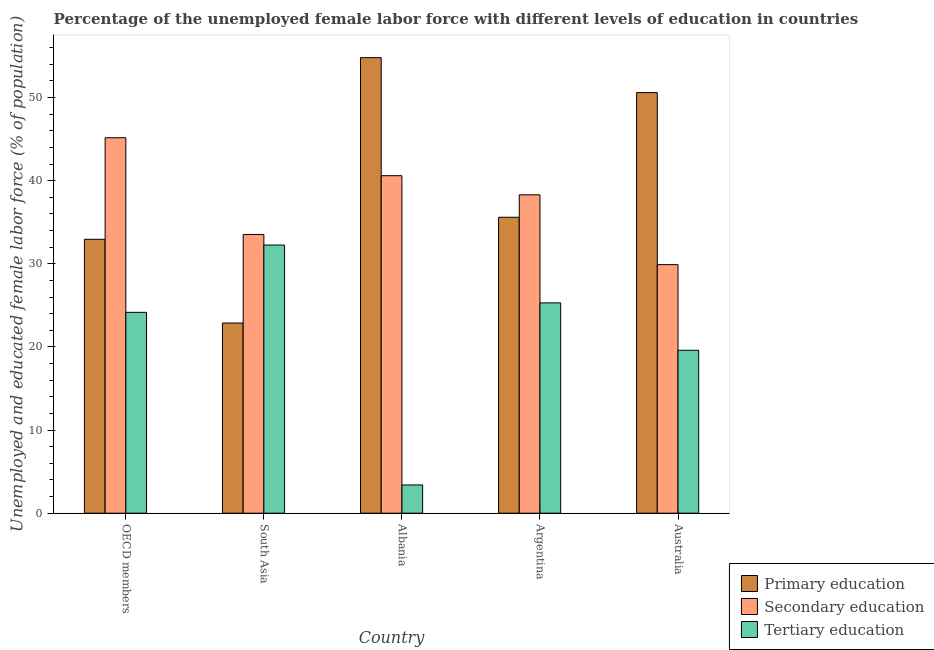Are the number of bars per tick equal to the number of legend labels?
Offer a terse response. Yes. Are the number of bars on each tick of the X-axis equal?
Keep it short and to the point. Yes. How many bars are there on the 3rd tick from the left?
Your answer should be compact. 3. How many bars are there on the 1st tick from the right?
Your answer should be very brief. 3. What is the label of the 3rd group of bars from the left?
Offer a terse response. Albania. What is the percentage of female labor force who received secondary education in South Asia?
Give a very brief answer. 33.53. Across all countries, what is the maximum percentage of female labor force who received primary education?
Your answer should be very brief. 54.8. Across all countries, what is the minimum percentage of female labor force who received secondary education?
Make the answer very short. 29.9. What is the total percentage of female labor force who received tertiary education in the graph?
Make the answer very short. 104.72. What is the difference between the percentage of female labor force who received secondary education in OECD members and that in South Asia?
Ensure brevity in your answer.  11.63. What is the difference between the percentage of female labor force who received secondary education in Argentina and the percentage of female labor force who received primary education in OECD members?
Make the answer very short. 5.35. What is the average percentage of female labor force who received secondary education per country?
Your response must be concise. 37.5. What is the difference between the percentage of female labor force who received primary education and percentage of female labor force who received secondary education in Albania?
Your answer should be very brief. 14.2. What is the ratio of the percentage of female labor force who received tertiary education in Albania to that in OECD members?
Ensure brevity in your answer.  0.14. Is the difference between the percentage of female labor force who received secondary education in Argentina and Australia greater than the difference between the percentage of female labor force who received primary education in Argentina and Australia?
Provide a succinct answer. Yes. What is the difference between the highest and the second highest percentage of female labor force who received tertiary education?
Provide a succinct answer. 6.96. What is the difference between the highest and the lowest percentage of female labor force who received tertiary education?
Keep it short and to the point. 28.86. Is the sum of the percentage of female labor force who received primary education in Albania and Australia greater than the maximum percentage of female labor force who received secondary education across all countries?
Your response must be concise. Yes. What does the 1st bar from the left in South Asia represents?
Ensure brevity in your answer.  Primary education. What does the 1st bar from the right in Argentina represents?
Your answer should be very brief. Tertiary education. Is it the case that in every country, the sum of the percentage of female labor force who received primary education and percentage of female labor force who received secondary education is greater than the percentage of female labor force who received tertiary education?
Keep it short and to the point. Yes. How many bars are there?
Your answer should be compact. 15. Are all the bars in the graph horizontal?
Give a very brief answer. No. What is the difference between two consecutive major ticks on the Y-axis?
Provide a short and direct response. 10. Are the values on the major ticks of Y-axis written in scientific E-notation?
Keep it short and to the point. No. What is the title of the graph?
Make the answer very short. Percentage of the unemployed female labor force with different levels of education in countries. Does "Oil" appear as one of the legend labels in the graph?
Make the answer very short. No. What is the label or title of the X-axis?
Your answer should be very brief. Country. What is the label or title of the Y-axis?
Your answer should be very brief. Unemployed and educated female labor force (% of population). What is the Unemployed and educated female labor force (% of population) of Primary education in OECD members?
Offer a very short reply. 32.95. What is the Unemployed and educated female labor force (% of population) in Secondary education in OECD members?
Ensure brevity in your answer.  45.16. What is the Unemployed and educated female labor force (% of population) of Tertiary education in OECD members?
Your answer should be compact. 24.16. What is the Unemployed and educated female labor force (% of population) of Primary education in South Asia?
Keep it short and to the point. 22.88. What is the Unemployed and educated female labor force (% of population) of Secondary education in South Asia?
Your answer should be very brief. 33.53. What is the Unemployed and educated female labor force (% of population) of Tertiary education in South Asia?
Offer a terse response. 32.26. What is the Unemployed and educated female labor force (% of population) of Primary education in Albania?
Your response must be concise. 54.8. What is the Unemployed and educated female labor force (% of population) in Secondary education in Albania?
Provide a short and direct response. 40.6. What is the Unemployed and educated female labor force (% of population) of Tertiary education in Albania?
Provide a short and direct response. 3.4. What is the Unemployed and educated female labor force (% of population) of Primary education in Argentina?
Provide a short and direct response. 35.6. What is the Unemployed and educated female labor force (% of population) of Secondary education in Argentina?
Provide a short and direct response. 38.3. What is the Unemployed and educated female labor force (% of population) in Tertiary education in Argentina?
Your answer should be compact. 25.3. What is the Unemployed and educated female labor force (% of population) in Primary education in Australia?
Keep it short and to the point. 50.6. What is the Unemployed and educated female labor force (% of population) in Secondary education in Australia?
Your answer should be very brief. 29.9. What is the Unemployed and educated female labor force (% of population) of Tertiary education in Australia?
Provide a succinct answer. 19.6. Across all countries, what is the maximum Unemployed and educated female labor force (% of population) of Primary education?
Offer a terse response. 54.8. Across all countries, what is the maximum Unemployed and educated female labor force (% of population) in Secondary education?
Make the answer very short. 45.16. Across all countries, what is the maximum Unemployed and educated female labor force (% of population) of Tertiary education?
Ensure brevity in your answer.  32.26. Across all countries, what is the minimum Unemployed and educated female labor force (% of population) of Primary education?
Offer a very short reply. 22.88. Across all countries, what is the minimum Unemployed and educated female labor force (% of population) of Secondary education?
Provide a short and direct response. 29.9. Across all countries, what is the minimum Unemployed and educated female labor force (% of population) in Tertiary education?
Your response must be concise. 3.4. What is the total Unemployed and educated female labor force (% of population) in Primary education in the graph?
Ensure brevity in your answer.  196.83. What is the total Unemployed and educated female labor force (% of population) in Secondary education in the graph?
Your answer should be very brief. 187.5. What is the total Unemployed and educated female labor force (% of population) of Tertiary education in the graph?
Your response must be concise. 104.72. What is the difference between the Unemployed and educated female labor force (% of population) of Primary education in OECD members and that in South Asia?
Ensure brevity in your answer.  10.07. What is the difference between the Unemployed and educated female labor force (% of population) in Secondary education in OECD members and that in South Asia?
Make the answer very short. 11.63. What is the difference between the Unemployed and educated female labor force (% of population) of Tertiary education in OECD members and that in South Asia?
Provide a short and direct response. -8.09. What is the difference between the Unemployed and educated female labor force (% of population) of Primary education in OECD members and that in Albania?
Provide a succinct answer. -21.85. What is the difference between the Unemployed and educated female labor force (% of population) of Secondary education in OECD members and that in Albania?
Provide a succinct answer. 4.56. What is the difference between the Unemployed and educated female labor force (% of population) in Tertiary education in OECD members and that in Albania?
Your response must be concise. 20.76. What is the difference between the Unemployed and educated female labor force (% of population) of Primary education in OECD members and that in Argentina?
Your response must be concise. -2.65. What is the difference between the Unemployed and educated female labor force (% of population) of Secondary education in OECD members and that in Argentina?
Make the answer very short. 6.86. What is the difference between the Unemployed and educated female labor force (% of population) in Tertiary education in OECD members and that in Argentina?
Provide a short and direct response. -1.14. What is the difference between the Unemployed and educated female labor force (% of population) in Primary education in OECD members and that in Australia?
Give a very brief answer. -17.65. What is the difference between the Unemployed and educated female labor force (% of population) in Secondary education in OECD members and that in Australia?
Offer a terse response. 15.26. What is the difference between the Unemployed and educated female labor force (% of population) in Tertiary education in OECD members and that in Australia?
Offer a terse response. 4.56. What is the difference between the Unemployed and educated female labor force (% of population) of Primary education in South Asia and that in Albania?
Provide a short and direct response. -31.92. What is the difference between the Unemployed and educated female labor force (% of population) of Secondary education in South Asia and that in Albania?
Make the answer very short. -7.07. What is the difference between the Unemployed and educated female labor force (% of population) in Tertiary education in South Asia and that in Albania?
Ensure brevity in your answer.  28.86. What is the difference between the Unemployed and educated female labor force (% of population) in Primary education in South Asia and that in Argentina?
Offer a very short reply. -12.72. What is the difference between the Unemployed and educated female labor force (% of population) of Secondary education in South Asia and that in Argentina?
Make the answer very short. -4.77. What is the difference between the Unemployed and educated female labor force (% of population) of Tertiary education in South Asia and that in Argentina?
Ensure brevity in your answer.  6.96. What is the difference between the Unemployed and educated female labor force (% of population) of Primary education in South Asia and that in Australia?
Provide a short and direct response. -27.72. What is the difference between the Unemployed and educated female labor force (% of population) of Secondary education in South Asia and that in Australia?
Keep it short and to the point. 3.63. What is the difference between the Unemployed and educated female labor force (% of population) in Tertiary education in South Asia and that in Australia?
Make the answer very short. 12.66. What is the difference between the Unemployed and educated female labor force (% of population) in Primary education in Albania and that in Argentina?
Your answer should be compact. 19.2. What is the difference between the Unemployed and educated female labor force (% of population) of Tertiary education in Albania and that in Argentina?
Ensure brevity in your answer.  -21.9. What is the difference between the Unemployed and educated female labor force (% of population) of Tertiary education in Albania and that in Australia?
Offer a terse response. -16.2. What is the difference between the Unemployed and educated female labor force (% of population) of Tertiary education in Argentina and that in Australia?
Your answer should be compact. 5.7. What is the difference between the Unemployed and educated female labor force (% of population) of Primary education in OECD members and the Unemployed and educated female labor force (% of population) of Secondary education in South Asia?
Provide a succinct answer. -0.58. What is the difference between the Unemployed and educated female labor force (% of population) of Primary education in OECD members and the Unemployed and educated female labor force (% of population) of Tertiary education in South Asia?
Keep it short and to the point. 0.69. What is the difference between the Unemployed and educated female labor force (% of population) in Secondary education in OECD members and the Unemployed and educated female labor force (% of population) in Tertiary education in South Asia?
Make the answer very short. 12.91. What is the difference between the Unemployed and educated female labor force (% of population) in Primary education in OECD members and the Unemployed and educated female labor force (% of population) in Secondary education in Albania?
Your answer should be compact. -7.65. What is the difference between the Unemployed and educated female labor force (% of population) of Primary education in OECD members and the Unemployed and educated female labor force (% of population) of Tertiary education in Albania?
Ensure brevity in your answer.  29.55. What is the difference between the Unemployed and educated female labor force (% of population) in Secondary education in OECD members and the Unemployed and educated female labor force (% of population) in Tertiary education in Albania?
Provide a succinct answer. 41.76. What is the difference between the Unemployed and educated female labor force (% of population) of Primary education in OECD members and the Unemployed and educated female labor force (% of population) of Secondary education in Argentina?
Your answer should be very brief. -5.35. What is the difference between the Unemployed and educated female labor force (% of population) of Primary education in OECD members and the Unemployed and educated female labor force (% of population) of Tertiary education in Argentina?
Provide a succinct answer. 7.65. What is the difference between the Unemployed and educated female labor force (% of population) of Secondary education in OECD members and the Unemployed and educated female labor force (% of population) of Tertiary education in Argentina?
Give a very brief answer. 19.86. What is the difference between the Unemployed and educated female labor force (% of population) in Primary education in OECD members and the Unemployed and educated female labor force (% of population) in Secondary education in Australia?
Ensure brevity in your answer.  3.05. What is the difference between the Unemployed and educated female labor force (% of population) of Primary education in OECD members and the Unemployed and educated female labor force (% of population) of Tertiary education in Australia?
Keep it short and to the point. 13.35. What is the difference between the Unemployed and educated female labor force (% of population) in Secondary education in OECD members and the Unemployed and educated female labor force (% of population) in Tertiary education in Australia?
Give a very brief answer. 25.56. What is the difference between the Unemployed and educated female labor force (% of population) of Primary education in South Asia and the Unemployed and educated female labor force (% of population) of Secondary education in Albania?
Your answer should be very brief. -17.72. What is the difference between the Unemployed and educated female labor force (% of population) of Primary education in South Asia and the Unemployed and educated female labor force (% of population) of Tertiary education in Albania?
Ensure brevity in your answer.  19.48. What is the difference between the Unemployed and educated female labor force (% of population) of Secondary education in South Asia and the Unemployed and educated female labor force (% of population) of Tertiary education in Albania?
Offer a terse response. 30.13. What is the difference between the Unemployed and educated female labor force (% of population) of Primary education in South Asia and the Unemployed and educated female labor force (% of population) of Secondary education in Argentina?
Your answer should be compact. -15.42. What is the difference between the Unemployed and educated female labor force (% of population) of Primary education in South Asia and the Unemployed and educated female labor force (% of population) of Tertiary education in Argentina?
Your answer should be compact. -2.42. What is the difference between the Unemployed and educated female labor force (% of population) of Secondary education in South Asia and the Unemployed and educated female labor force (% of population) of Tertiary education in Argentina?
Offer a terse response. 8.23. What is the difference between the Unemployed and educated female labor force (% of population) of Primary education in South Asia and the Unemployed and educated female labor force (% of population) of Secondary education in Australia?
Your answer should be compact. -7.02. What is the difference between the Unemployed and educated female labor force (% of population) of Primary education in South Asia and the Unemployed and educated female labor force (% of population) of Tertiary education in Australia?
Keep it short and to the point. 3.28. What is the difference between the Unemployed and educated female labor force (% of population) of Secondary education in South Asia and the Unemployed and educated female labor force (% of population) of Tertiary education in Australia?
Keep it short and to the point. 13.93. What is the difference between the Unemployed and educated female labor force (% of population) of Primary education in Albania and the Unemployed and educated female labor force (% of population) of Secondary education in Argentina?
Offer a terse response. 16.5. What is the difference between the Unemployed and educated female labor force (% of population) of Primary education in Albania and the Unemployed and educated female labor force (% of population) of Tertiary education in Argentina?
Make the answer very short. 29.5. What is the difference between the Unemployed and educated female labor force (% of population) in Secondary education in Albania and the Unemployed and educated female labor force (% of population) in Tertiary education in Argentina?
Give a very brief answer. 15.3. What is the difference between the Unemployed and educated female labor force (% of population) of Primary education in Albania and the Unemployed and educated female labor force (% of population) of Secondary education in Australia?
Ensure brevity in your answer.  24.9. What is the difference between the Unemployed and educated female labor force (% of population) of Primary education in Albania and the Unemployed and educated female labor force (% of population) of Tertiary education in Australia?
Offer a very short reply. 35.2. What is the difference between the Unemployed and educated female labor force (% of population) of Primary education in Argentina and the Unemployed and educated female labor force (% of population) of Secondary education in Australia?
Your answer should be compact. 5.7. What is the difference between the Unemployed and educated female labor force (% of population) of Secondary education in Argentina and the Unemployed and educated female labor force (% of population) of Tertiary education in Australia?
Provide a short and direct response. 18.7. What is the average Unemployed and educated female labor force (% of population) in Primary education per country?
Offer a terse response. 39.37. What is the average Unemployed and educated female labor force (% of population) in Secondary education per country?
Your answer should be compact. 37.5. What is the average Unemployed and educated female labor force (% of population) in Tertiary education per country?
Offer a very short reply. 20.94. What is the difference between the Unemployed and educated female labor force (% of population) of Primary education and Unemployed and educated female labor force (% of population) of Secondary education in OECD members?
Make the answer very short. -12.22. What is the difference between the Unemployed and educated female labor force (% of population) in Primary education and Unemployed and educated female labor force (% of population) in Tertiary education in OECD members?
Your answer should be very brief. 8.78. What is the difference between the Unemployed and educated female labor force (% of population) of Secondary education and Unemployed and educated female labor force (% of population) of Tertiary education in OECD members?
Make the answer very short. 21. What is the difference between the Unemployed and educated female labor force (% of population) of Primary education and Unemployed and educated female labor force (% of population) of Secondary education in South Asia?
Your response must be concise. -10.65. What is the difference between the Unemployed and educated female labor force (% of population) in Primary education and Unemployed and educated female labor force (% of population) in Tertiary education in South Asia?
Offer a very short reply. -9.38. What is the difference between the Unemployed and educated female labor force (% of population) in Secondary education and Unemployed and educated female labor force (% of population) in Tertiary education in South Asia?
Make the answer very short. 1.27. What is the difference between the Unemployed and educated female labor force (% of population) of Primary education and Unemployed and educated female labor force (% of population) of Secondary education in Albania?
Your answer should be very brief. 14.2. What is the difference between the Unemployed and educated female labor force (% of population) in Primary education and Unemployed and educated female labor force (% of population) in Tertiary education in Albania?
Ensure brevity in your answer.  51.4. What is the difference between the Unemployed and educated female labor force (% of population) in Secondary education and Unemployed and educated female labor force (% of population) in Tertiary education in Albania?
Offer a terse response. 37.2. What is the difference between the Unemployed and educated female labor force (% of population) in Primary education and Unemployed and educated female labor force (% of population) in Secondary education in Australia?
Ensure brevity in your answer.  20.7. What is the difference between the Unemployed and educated female labor force (% of population) of Primary education and Unemployed and educated female labor force (% of population) of Tertiary education in Australia?
Provide a short and direct response. 31. What is the difference between the Unemployed and educated female labor force (% of population) in Secondary education and Unemployed and educated female labor force (% of population) in Tertiary education in Australia?
Provide a succinct answer. 10.3. What is the ratio of the Unemployed and educated female labor force (% of population) of Primary education in OECD members to that in South Asia?
Provide a short and direct response. 1.44. What is the ratio of the Unemployed and educated female labor force (% of population) of Secondary education in OECD members to that in South Asia?
Give a very brief answer. 1.35. What is the ratio of the Unemployed and educated female labor force (% of population) of Tertiary education in OECD members to that in South Asia?
Give a very brief answer. 0.75. What is the ratio of the Unemployed and educated female labor force (% of population) in Primary education in OECD members to that in Albania?
Keep it short and to the point. 0.6. What is the ratio of the Unemployed and educated female labor force (% of population) in Secondary education in OECD members to that in Albania?
Keep it short and to the point. 1.11. What is the ratio of the Unemployed and educated female labor force (% of population) of Tertiary education in OECD members to that in Albania?
Your answer should be very brief. 7.11. What is the ratio of the Unemployed and educated female labor force (% of population) of Primary education in OECD members to that in Argentina?
Ensure brevity in your answer.  0.93. What is the ratio of the Unemployed and educated female labor force (% of population) of Secondary education in OECD members to that in Argentina?
Offer a terse response. 1.18. What is the ratio of the Unemployed and educated female labor force (% of population) in Tertiary education in OECD members to that in Argentina?
Give a very brief answer. 0.96. What is the ratio of the Unemployed and educated female labor force (% of population) of Primary education in OECD members to that in Australia?
Provide a succinct answer. 0.65. What is the ratio of the Unemployed and educated female labor force (% of population) of Secondary education in OECD members to that in Australia?
Provide a succinct answer. 1.51. What is the ratio of the Unemployed and educated female labor force (% of population) of Tertiary education in OECD members to that in Australia?
Offer a terse response. 1.23. What is the ratio of the Unemployed and educated female labor force (% of population) in Primary education in South Asia to that in Albania?
Provide a short and direct response. 0.42. What is the ratio of the Unemployed and educated female labor force (% of population) in Secondary education in South Asia to that in Albania?
Provide a short and direct response. 0.83. What is the ratio of the Unemployed and educated female labor force (% of population) in Tertiary education in South Asia to that in Albania?
Your response must be concise. 9.49. What is the ratio of the Unemployed and educated female labor force (% of population) of Primary education in South Asia to that in Argentina?
Provide a succinct answer. 0.64. What is the ratio of the Unemployed and educated female labor force (% of population) of Secondary education in South Asia to that in Argentina?
Ensure brevity in your answer.  0.88. What is the ratio of the Unemployed and educated female labor force (% of population) in Tertiary education in South Asia to that in Argentina?
Your answer should be compact. 1.27. What is the ratio of the Unemployed and educated female labor force (% of population) in Primary education in South Asia to that in Australia?
Provide a short and direct response. 0.45. What is the ratio of the Unemployed and educated female labor force (% of population) of Secondary education in South Asia to that in Australia?
Your answer should be compact. 1.12. What is the ratio of the Unemployed and educated female labor force (% of population) in Tertiary education in South Asia to that in Australia?
Ensure brevity in your answer.  1.65. What is the ratio of the Unemployed and educated female labor force (% of population) in Primary education in Albania to that in Argentina?
Give a very brief answer. 1.54. What is the ratio of the Unemployed and educated female labor force (% of population) of Secondary education in Albania to that in Argentina?
Your answer should be compact. 1.06. What is the ratio of the Unemployed and educated female labor force (% of population) in Tertiary education in Albania to that in Argentina?
Keep it short and to the point. 0.13. What is the ratio of the Unemployed and educated female labor force (% of population) in Primary education in Albania to that in Australia?
Give a very brief answer. 1.08. What is the ratio of the Unemployed and educated female labor force (% of population) of Secondary education in Albania to that in Australia?
Your answer should be very brief. 1.36. What is the ratio of the Unemployed and educated female labor force (% of population) in Tertiary education in Albania to that in Australia?
Your response must be concise. 0.17. What is the ratio of the Unemployed and educated female labor force (% of population) of Primary education in Argentina to that in Australia?
Your answer should be compact. 0.7. What is the ratio of the Unemployed and educated female labor force (% of population) in Secondary education in Argentina to that in Australia?
Give a very brief answer. 1.28. What is the ratio of the Unemployed and educated female labor force (% of population) in Tertiary education in Argentina to that in Australia?
Ensure brevity in your answer.  1.29. What is the difference between the highest and the second highest Unemployed and educated female labor force (% of population) of Primary education?
Your response must be concise. 4.2. What is the difference between the highest and the second highest Unemployed and educated female labor force (% of population) of Secondary education?
Provide a short and direct response. 4.56. What is the difference between the highest and the second highest Unemployed and educated female labor force (% of population) of Tertiary education?
Provide a short and direct response. 6.96. What is the difference between the highest and the lowest Unemployed and educated female labor force (% of population) of Primary education?
Your answer should be compact. 31.92. What is the difference between the highest and the lowest Unemployed and educated female labor force (% of population) in Secondary education?
Your response must be concise. 15.26. What is the difference between the highest and the lowest Unemployed and educated female labor force (% of population) in Tertiary education?
Ensure brevity in your answer.  28.86. 